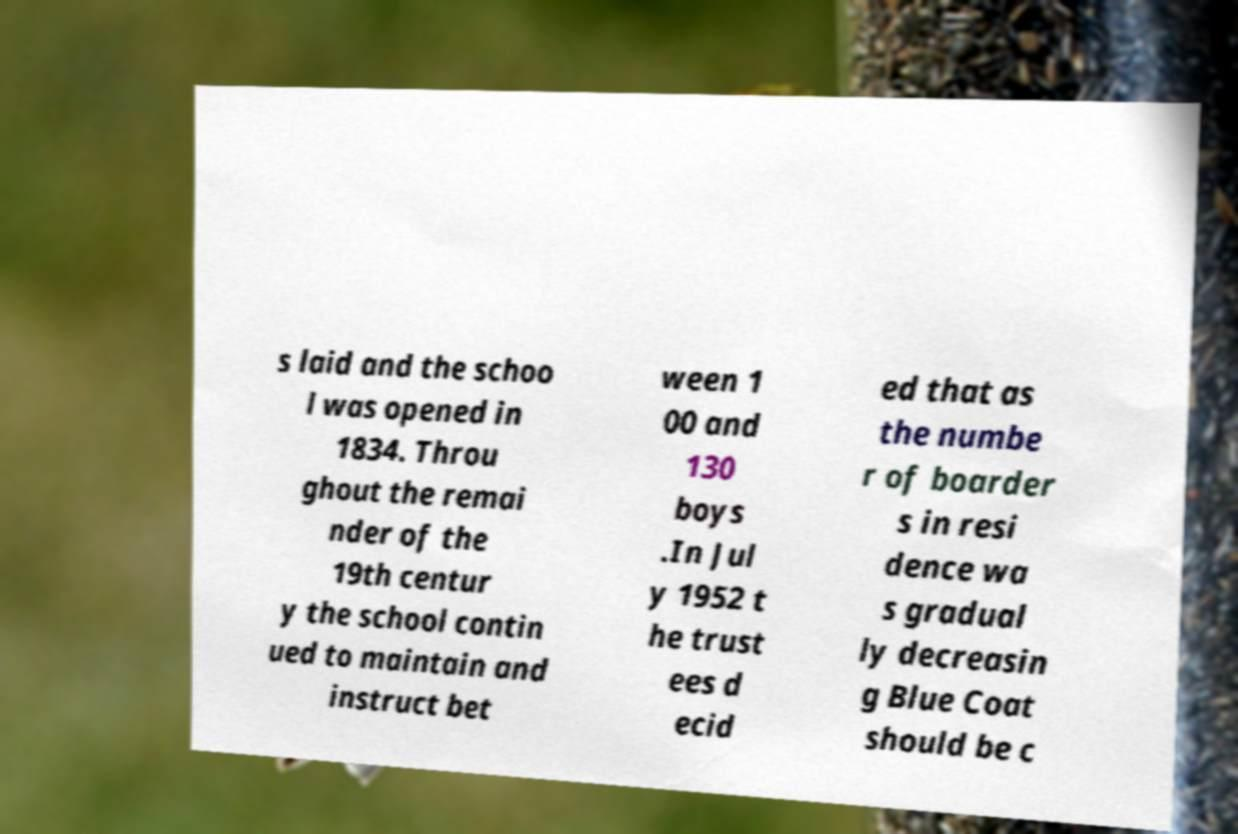There's text embedded in this image that I need extracted. Can you transcribe it verbatim? s laid and the schoo l was opened in 1834. Throu ghout the remai nder of the 19th centur y the school contin ued to maintain and instruct bet ween 1 00 and 130 boys .In Jul y 1952 t he trust ees d ecid ed that as the numbe r of boarder s in resi dence wa s gradual ly decreasin g Blue Coat should be c 